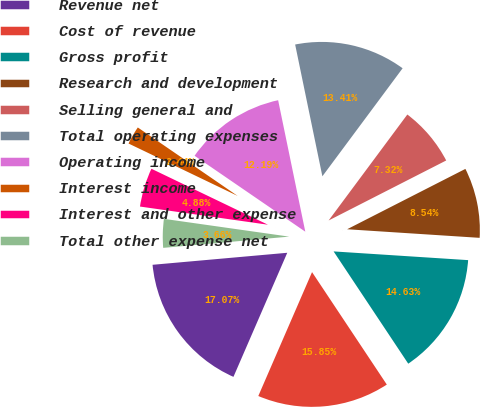<chart> <loc_0><loc_0><loc_500><loc_500><pie_chart><fcel>Revenue net<fcel>Cost of revenue<fcel>Gross profit<fcel>Research and development<fcel>Selling general and<fcel>Total operating expenses<fcel>Operating income<fcel>Interest income<fcel>Interest and other expense<fcel>Total other expense net<nl><fcel>17.07%<fcel>15.85%<fcel>14.63%<fcel>8.54%<fcel>7.32%<fcel>13.41%<fcel>12.19%<fcel>2.44%<fcel>4.88%<fcel>3.66%<nl></chart> 